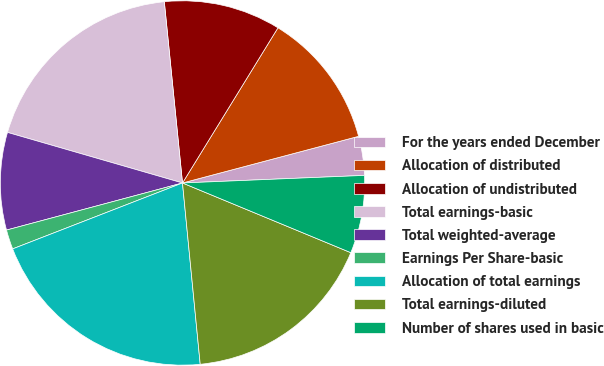Convert chart to OTSL. <chart><loc_0><loc_0><loc_500><loc_500><pie_chart><fcel>For the years ended December<fcel>Allocation of distributed<fcel>Allocation of undistributed<fcel>Total earnings-basic<fcel>Total weighted-average<fcel>Earnings Per Share-basic<fcel>Allocation of total earnings<fcel>Total earnings-diluted<fcel>Number of shares used in basic<nl><fcel>3.46%<fcel>12.1%<fcel>10.37%<fcel>18.93%<fcel>8.64%<fcel>1.73%<fcel>20.66%<fcel>17.2%<fcel>6.91%<nl></chart> 